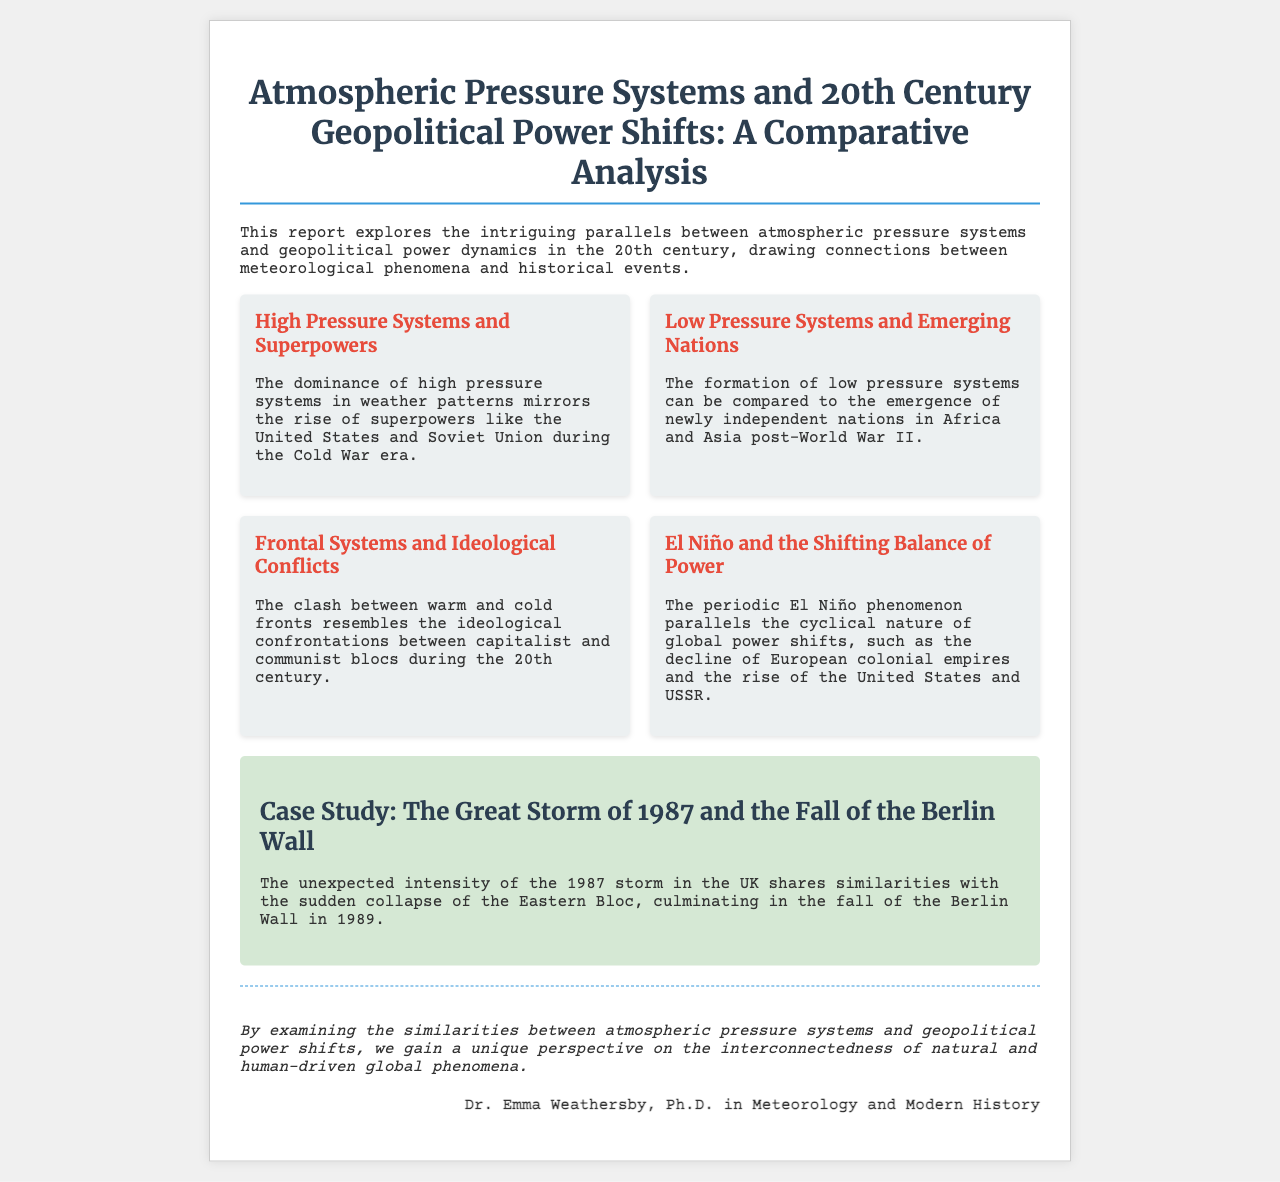What is the title of the report? The title is found at the top of the document and provides the main focus of the research.
Answer: Atmospheric Pressure Systems and 20th Century Geopolitical Power Shifts: A Comparative Analysis Who is the author of the report? The document includes a section at the end that specifies the author's name and credentials.
Answer: Dr. Emma Weathersby, Ph.D. in Meteorology and Modern History What phenomenon parallels the rise of superpowers? The document mentions key points that draw parallels between atmospheric and geopolitical phenomena, specifically here.
Answer: High pressure systems What significant event is discussed in the case study? The case study section highlights a historical event in relation to a specific meteorological event.
Answer: The Great Storm of 1987 What year did the fall of the Berlin Wall occur? This date is critical to the historical context provided in the case study of the document.
Answer: 1989 What do low pressure systems represent in the context of emerging nations? The key point elaborates on how certain meteorological phenomena relate to historical developments.
Answer: Newly independent nations Which two superpowers are mentioned during the Cold War era? The document references well-known global powers during a significant geopolitical period.
Answer: United States and Soviet Union What does the clash between warm and cold fronts resemble? This key point draws a direct analogy using meteorological terms and historical ideologies.
Answer: Ideological confrontations 